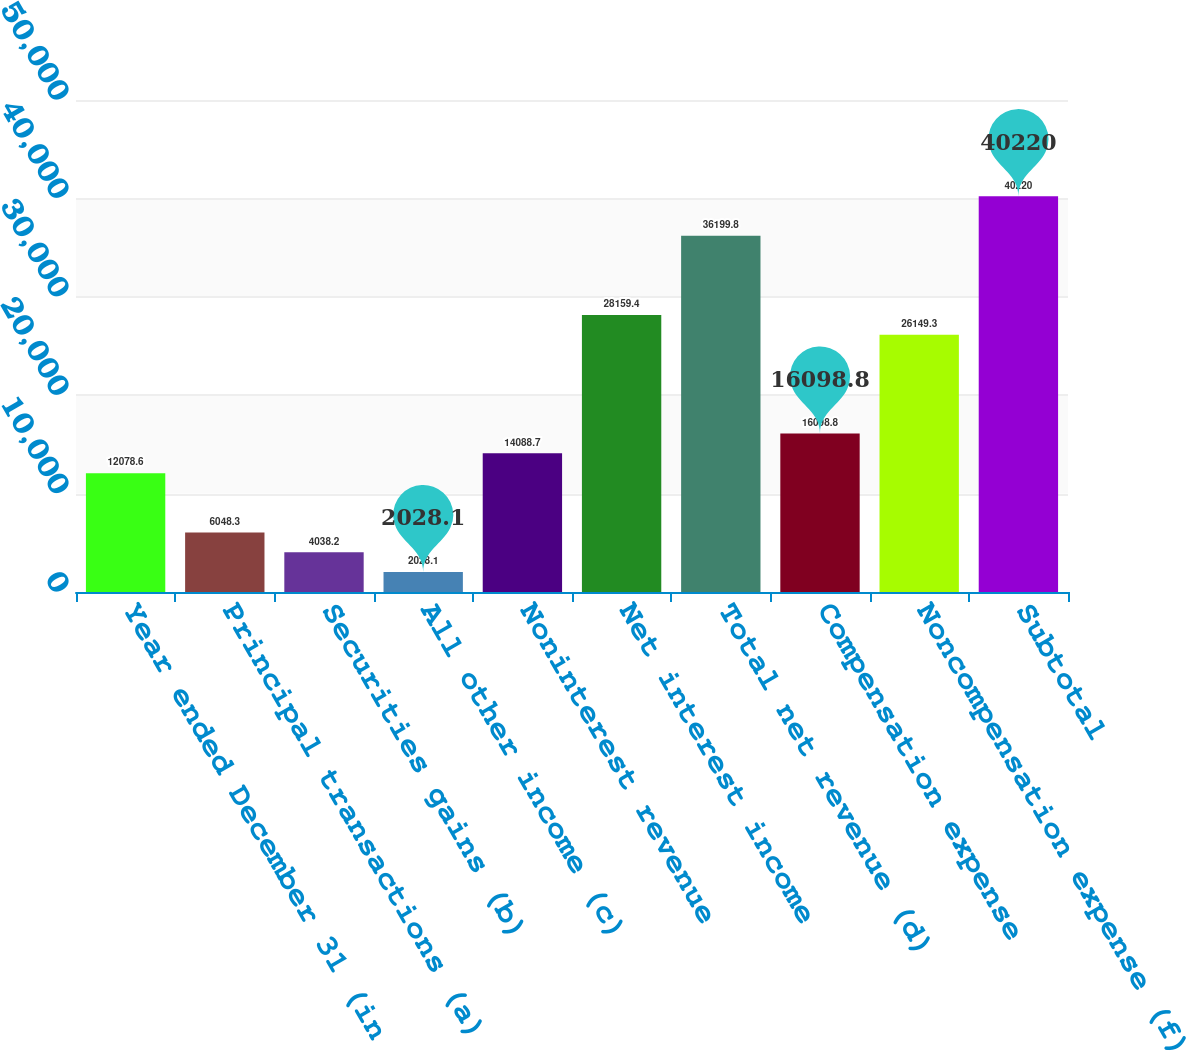Convert chart to OTSL. <chart><loc_0><loc_0><loc_500><loc_500><bar_chart><fcel>Year ended December 31 (in<fcel>Principal transactions (a)<fcel>Securities gains (b)<fcel>All other income (c)<fcel>Noninterest revenue<fcel>Net interest income<fcel>Total net revenue (d)<fcel>Compensation expense<fcel>Noncompensation expense (f)<fcel>Subtotal<nl><fcel>12078.6<fcel>6048.3<fcel>4038.2<fcel>2028.1<fcel>14088.7<fcel>28159.4<fcel>36199.8<fcel>16098.8<fcel>26149.3<fcel>40220<nl></chart> 